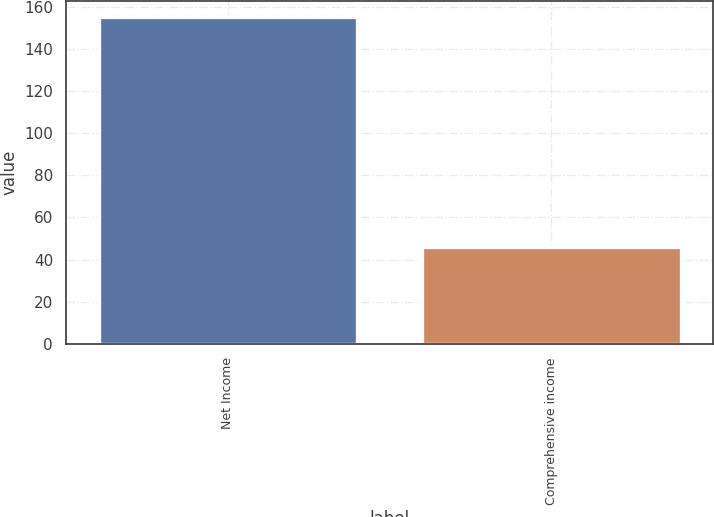Convert chart to OTSL. <chart><loc_0><loc_0><loc_500><loc_500><bar_chart><fcel>Net Income<fcel>Comprehensive income<nl><fcel>155<fcel>46<nl></chart> 